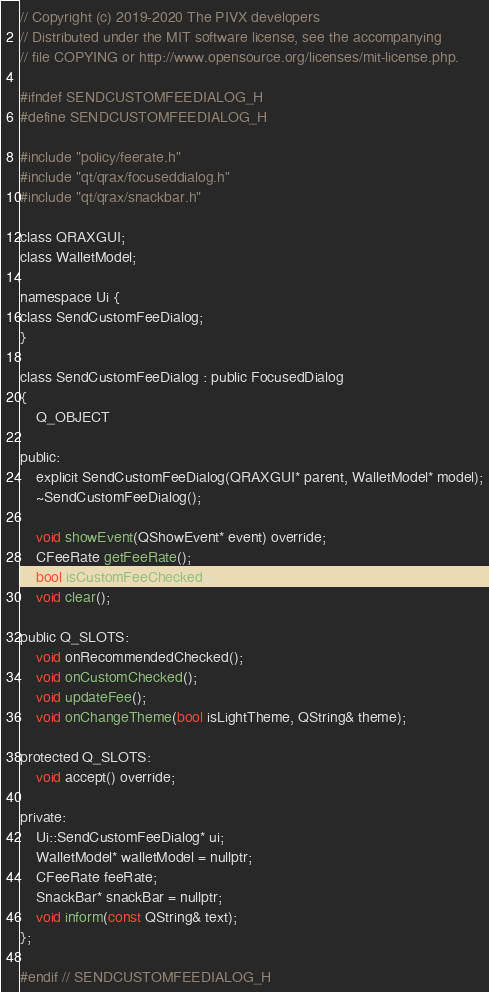<code> <loc_0><loc_0><loc_500><loc_500><_C_>// Copyright (c) 2019-2020 The PIVX developers
// Distributed under the MIT software license, see the accompanying
// file COPYING or http://www.opensource.org/licenses/mit-license.php.

#ifndef SENDCUSTOMFEEDIALOG_H
#define SENDCUSTOMFEEDIALOG_H

#include "policy/feerate.h"
#include "qt/qrax/focuseddialog.h"
#include "qt/qrax/snackbar.h"

class QRAXGUI;
class WalletModel;

namespace Ui {
class SendCustomFeeDialog;
}

class SendCustomFeeDialog : public FocusedDialog
{
    Q_OBJECT

public:
    explicit SendCustomFeeDialog(QRAXGUI* parent, WalletModel* model);
    ~SendCustomFeeDialog();

    void showEvent(QShowEvent* event) override;
    CFeeRate getFeeRate();
    bool isCustomFeeChecked();
    void clear();

public Q_SLOTS:
    void onRecommendedChecked();
    void onCustomChecked();
    void updateFee();
    void onChangeTheme(bool isLightTheme, QString& theme);

protected Q_SLOTS:
    void accept() override;

private:
    Ui::SendCustomFeeDialog* ui;
    WalletModel* walletModel = nullptr;
    CFeeRate feeRate;
    SnackBar* snackBar = nullptr;
    void inform(const QString& text);
};

#endif // SENDCUSTOMFEEDIALOG_H
</code> 